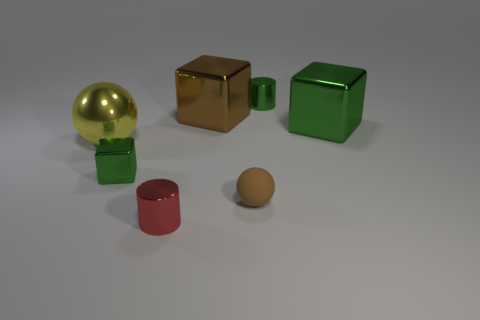There is a thing that is the same color as the rubber sphere; what is its size?
Keep it short and to the point. Large. Are there an equal number of metallic cylinders behind the large ball and large green cubes?
Keep it short and to the point. Yes. Do the brown matte sphere and the red cylinder have the same size?
Ensure brevity in your answer.  Yes. The metal block that is the same size as the red cylinder is what color?
Your answer should be very brief. Green. Is the size of the metallic ball the same as the green metal cube left of the small red object?
Keep it short and to the point. No. How many metal cubes are the same color as the tiny rubber sphere?
Provide a succinct answer. 1. What number of objects are either tiny red metallic things or objects that are to the right of the rubber object?
Make the answer very short. 3. Do the red cylinder in front of the small green shiny block and the object left of the tiny block have the same size?
Offer a terse response. No. Are there any large cyan cylinders that have the same material as the large green block?
Provide a short and direct response. No. There is a big yellow object; what shape is it?
Ensure brevity in your answer.  Sphere. 